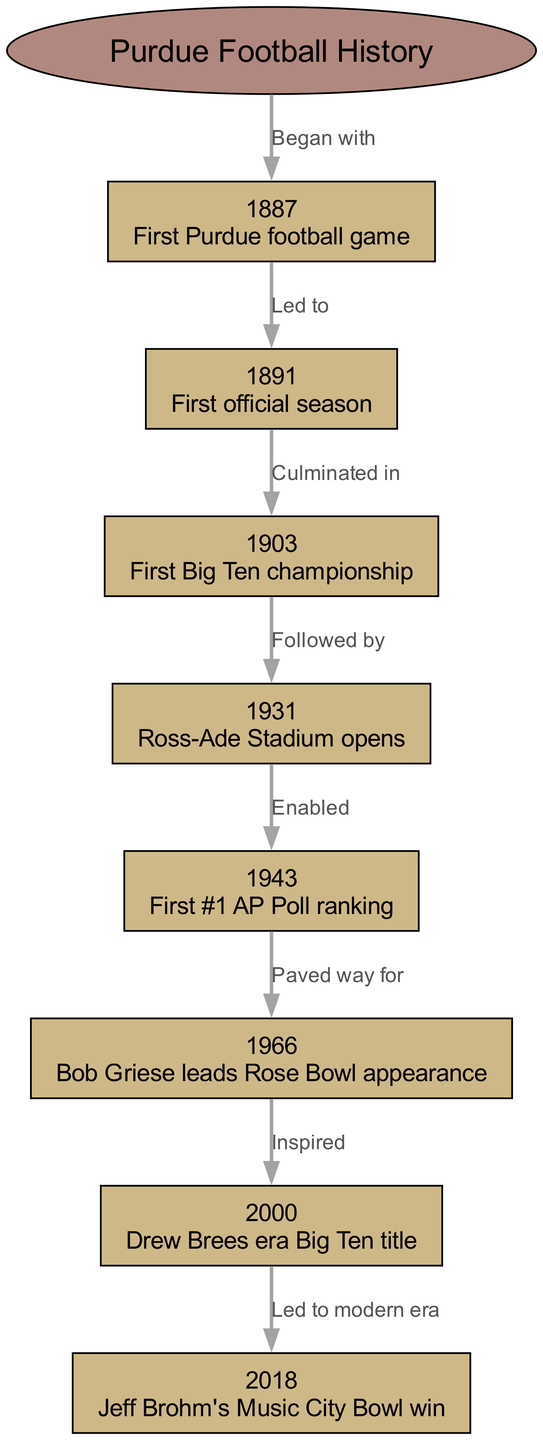What year did Purdue football play its first game? The diagram indicates that Purdue football's first game took place in the year labeled "1887." This can be found directly in the node for the first game.
Answer: 1887 What was significant about the year 1903 for Purdue football? According to the diagram, the year 1903 is associated with Purdue winning its first Big Ten championship, which is labeled clearly in the corresponding node.
Answer: First Big Ten championship Which milestone occurred after the opening of Ross-Ade Stadium in 1931? The diagram shows a flow from the "1931" node, which indicates that after the stadium opened, the first #1 AP Poll ranking occurred in 1943. This is evident from the edge connecting the two nodes.
Answer: First #1 AP Poll ranking How many total nodes are there in the concept map? The diagram lists a total of eight nodes, including the central concept, its surrounding milestones, and events. This can be counted directly from the nodes provided in the diagram.
Answer: 8 Which event in 2000 is connected to modern Purdue football? The diagram illustrates a direct connection from the "2000" node, which signifies the Big Ten title during the Drew Brees era, leading to the modern era of Purdue football as indicated in the edge label.
Answer: Drew Brees era Big Ten title What event enabled the first #1 AP Poll ranking for Purdue? The diagram states that the opening of Ross-Ade Stadium in 1931 enabled the first #1 AP Poll ranking in 1943. This is shown through the edge that connects these two nodes with the label "Enabled."
Answer: Ross-Ade Stadium opens What did Bob Griese's achievement in 1966 inspire? The diagram describes an inspiration link from the 1966 node, which marks Bob Griese's Rose Bowl appearance, leading to significant developments in the following years, including the year 2000. This flow shows a chronological progression that links Griese's event to future successes.
Answer: Drew Brees era Big Ten title In what year did Purdue achieve its first official season? According to the diagram, the first official season of Purdue football is highlighted in the year 1891, which connects directly after the first game node.
Answer: 1891 